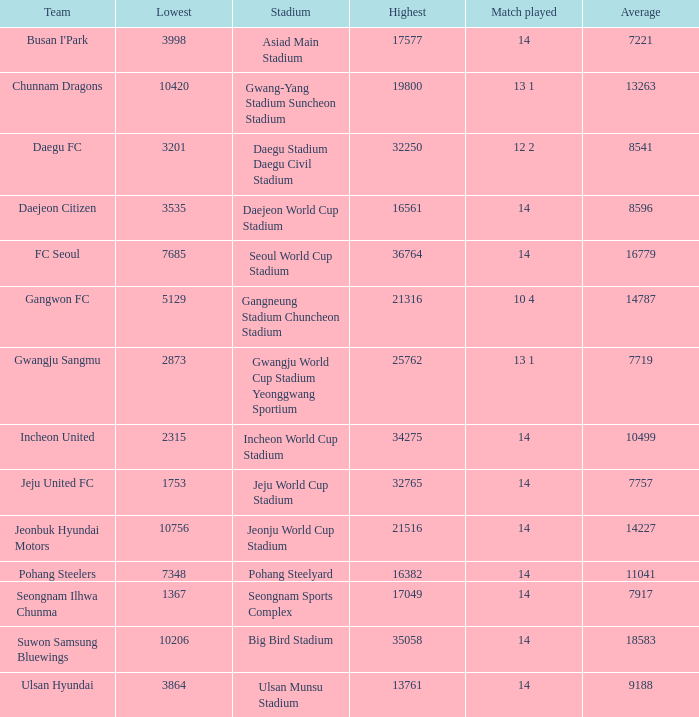Which team has a match played of 10 4? Gangwon FC. 